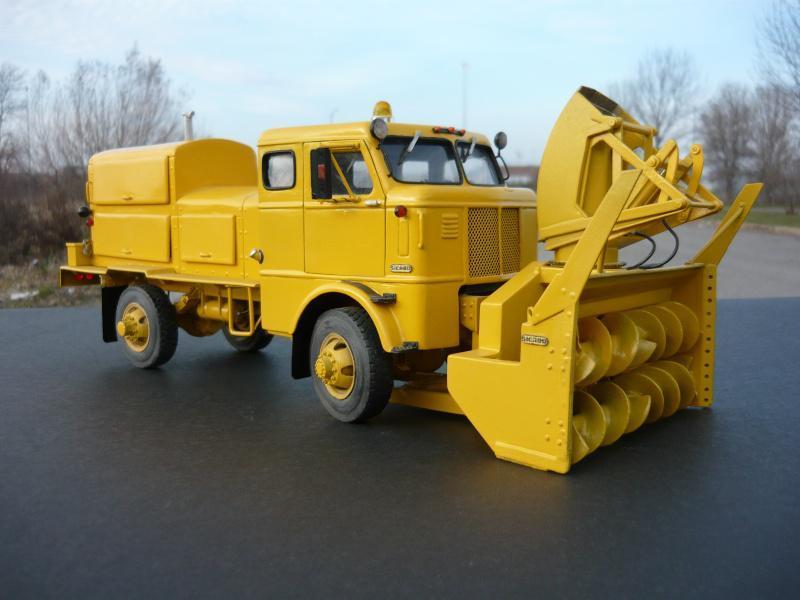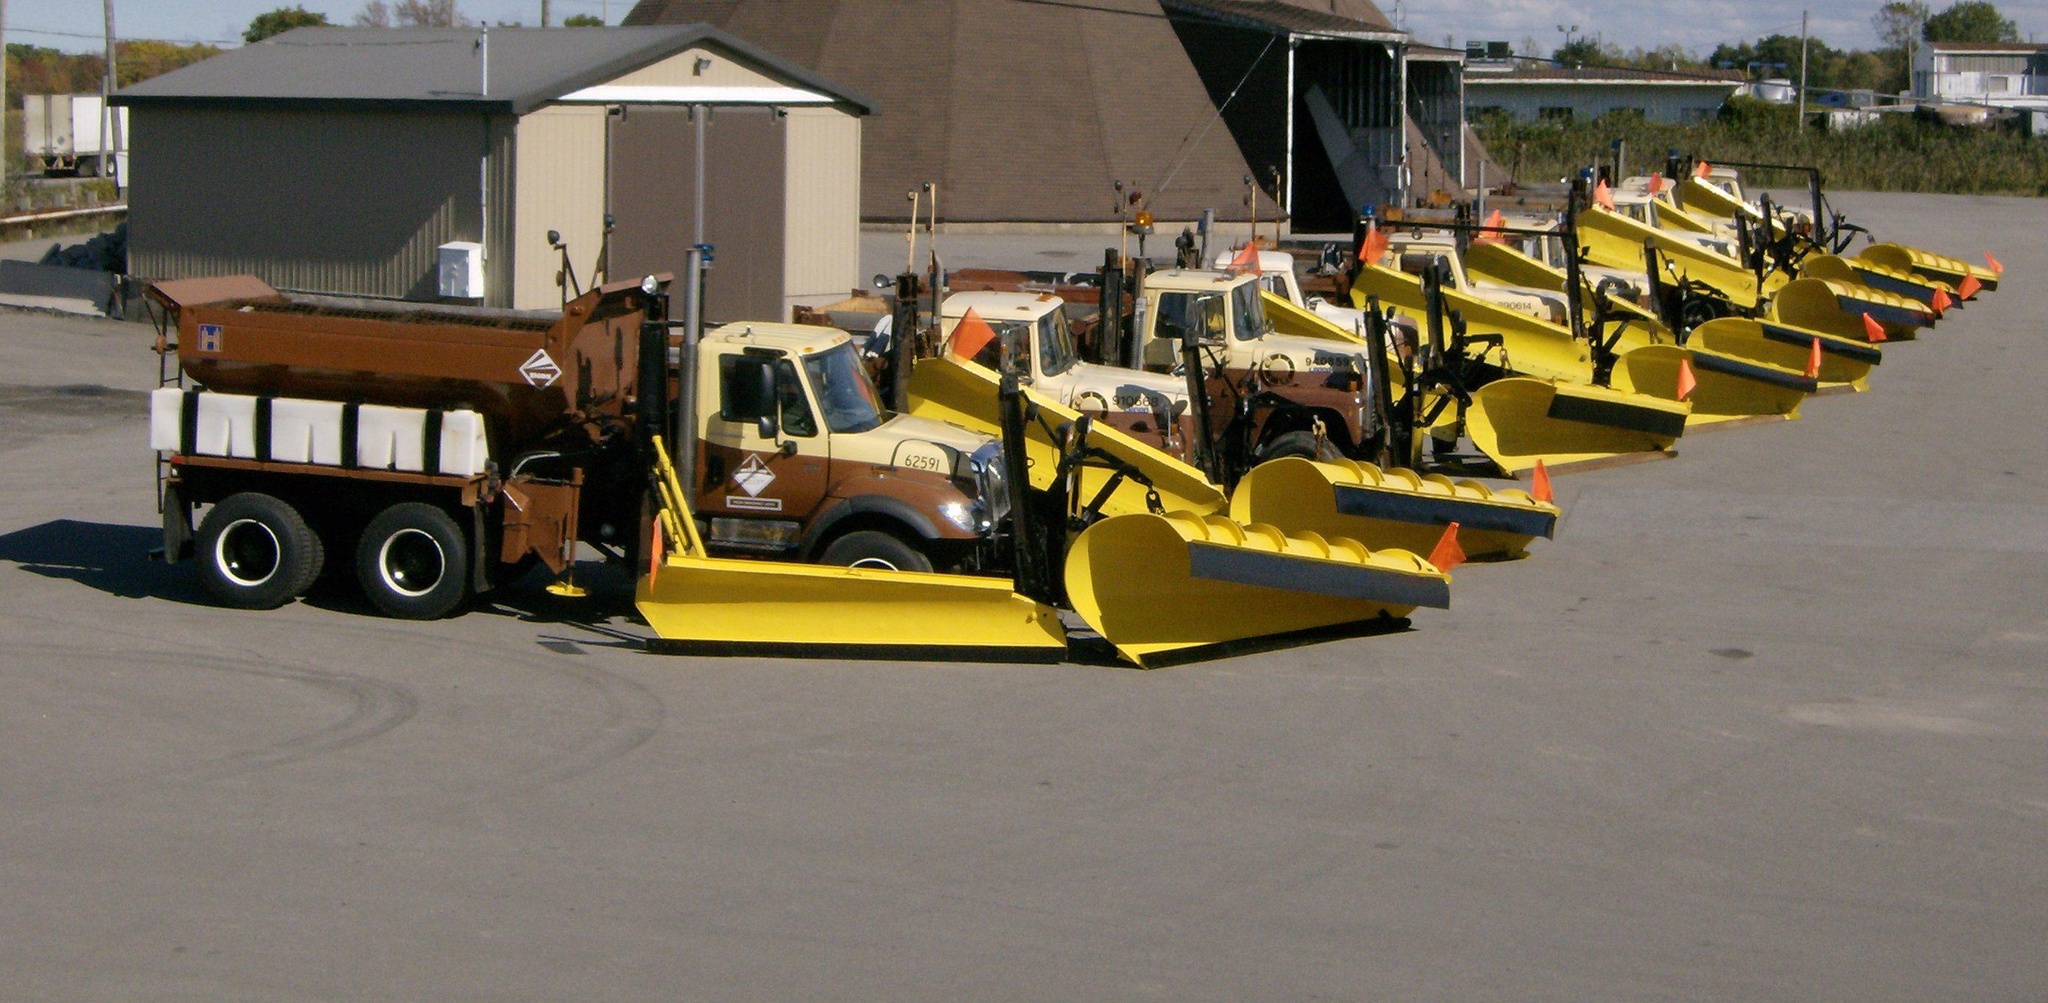The first image is the image on the left, the second image is the image on the right. For the images shown, is this caption "At least one snow plow is driving down the road clearing snow." true? Answer yes or no. No. The first image is the image on the left, the second image is the image on the right. Considering the images on both sides, is "None of these trucks are pushing snow." valid? Answer yes or no. Yes. 